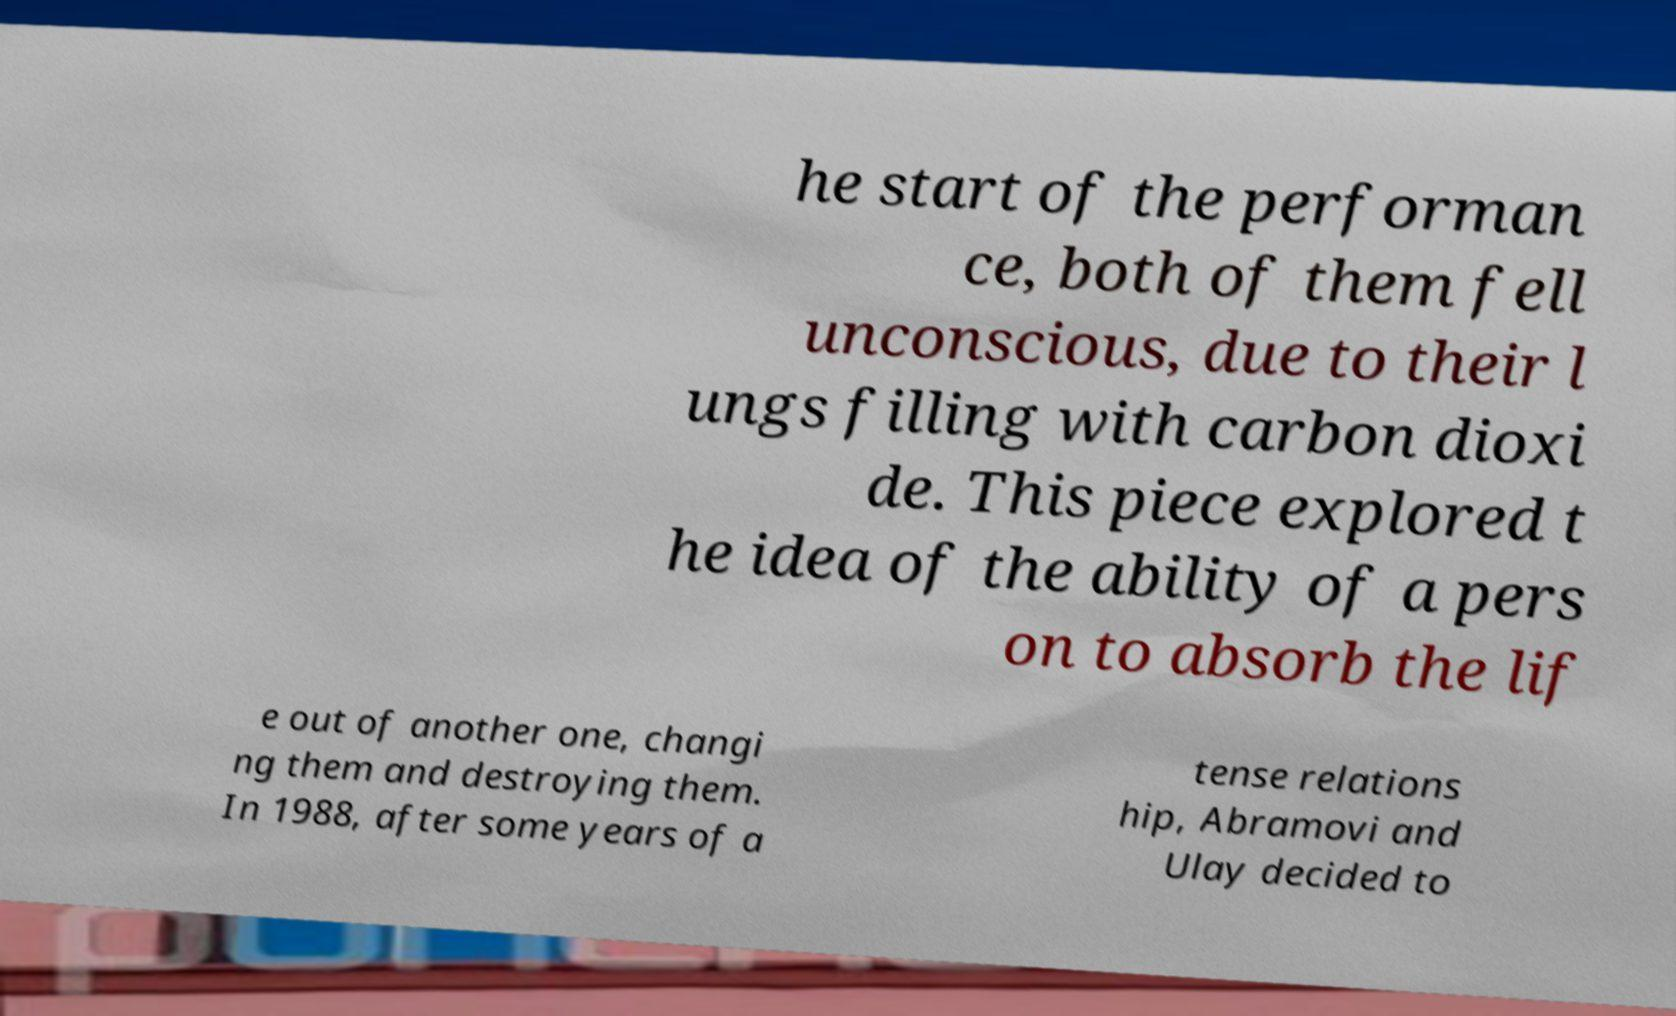What messages or text are displayed in this image? I need them in a readable, typed format. he start of the performan ce, both of them fell unconscious, due to their l ungs filling with carbon dioxi de. This piece explored t he idea of the ability of a pers on to absorb the lif e out of another one, changi ng them and destroying them. In 1988, after some years of a tense relations hip, Abramovi and Ulay decided to 